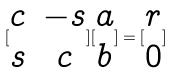<formula> <loc_0><loc_0><loc_500><loc_500>[ \begin{matrix} c & - s \\ s & c \end{matrix} ] [ \begin{matrix} a \\ b \end{matrix} ] = [ \begin{matrix} r \\ 0 \end{matrix} ]</formula> 